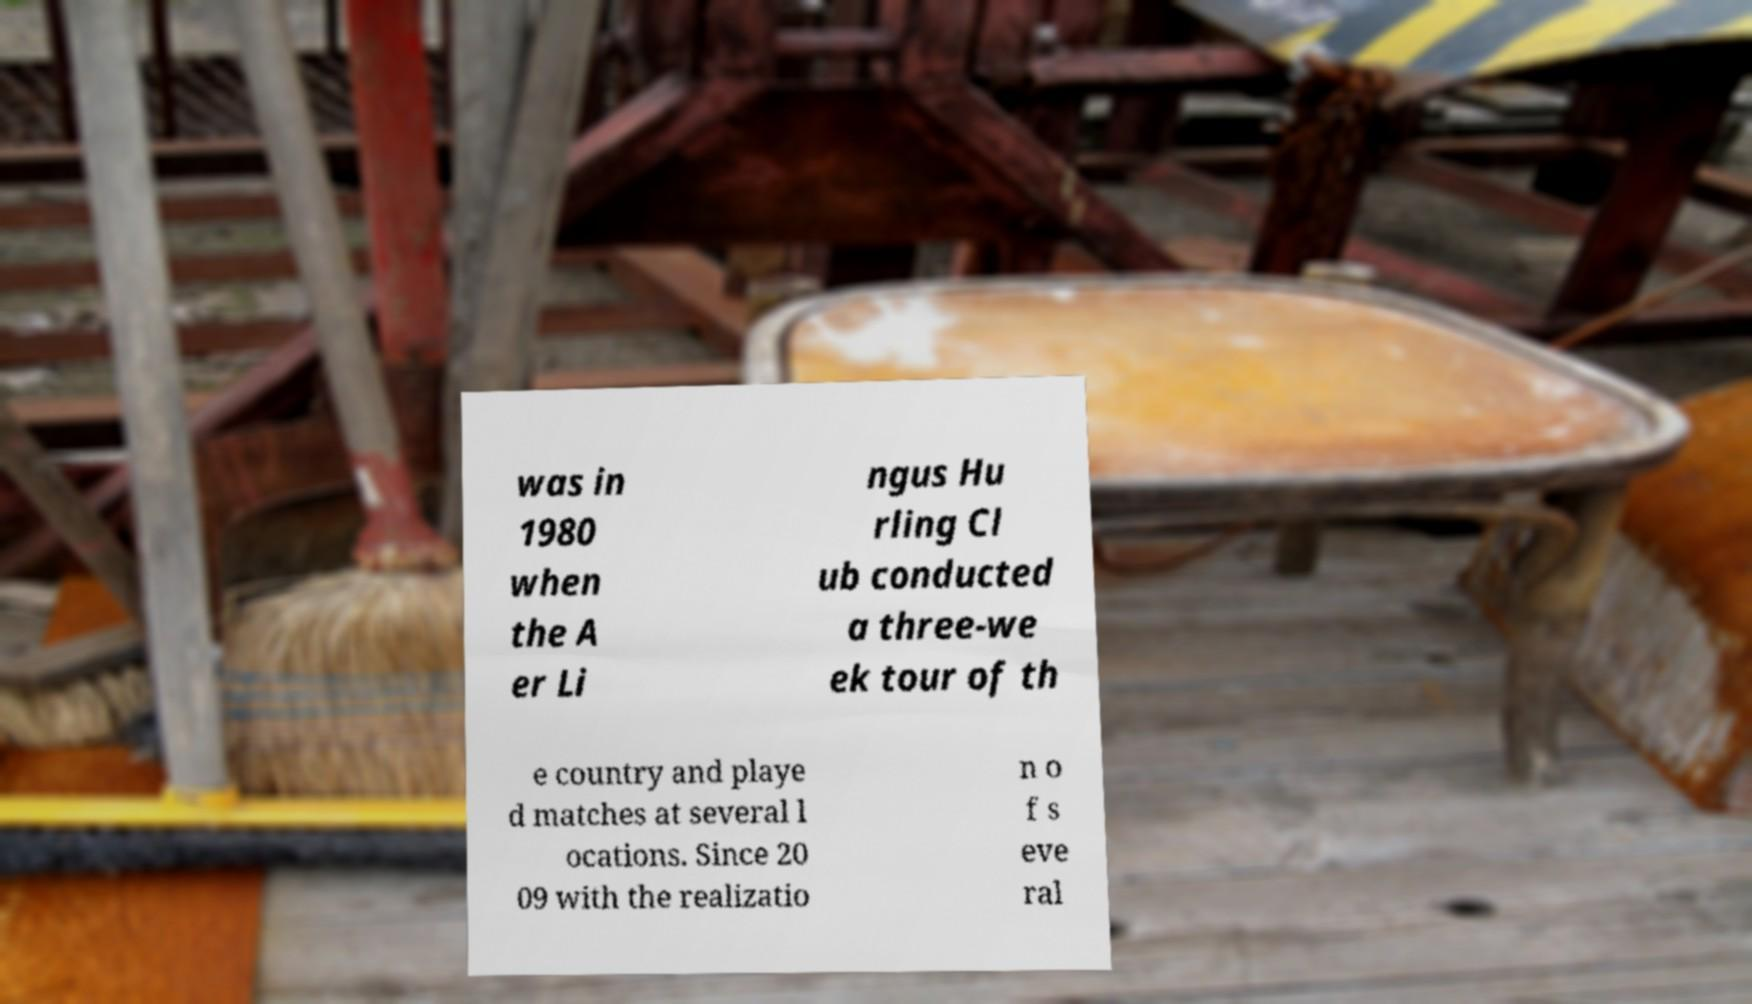I need the written content from this picture converted into text. Can you do that? was in 1980 when the A er Li ngus Hu rling Cl ub conducted a three-we ek tour of th e country and playe d matches at several l ocations. Since 20 09 with the realizatio n o f s eve ral 